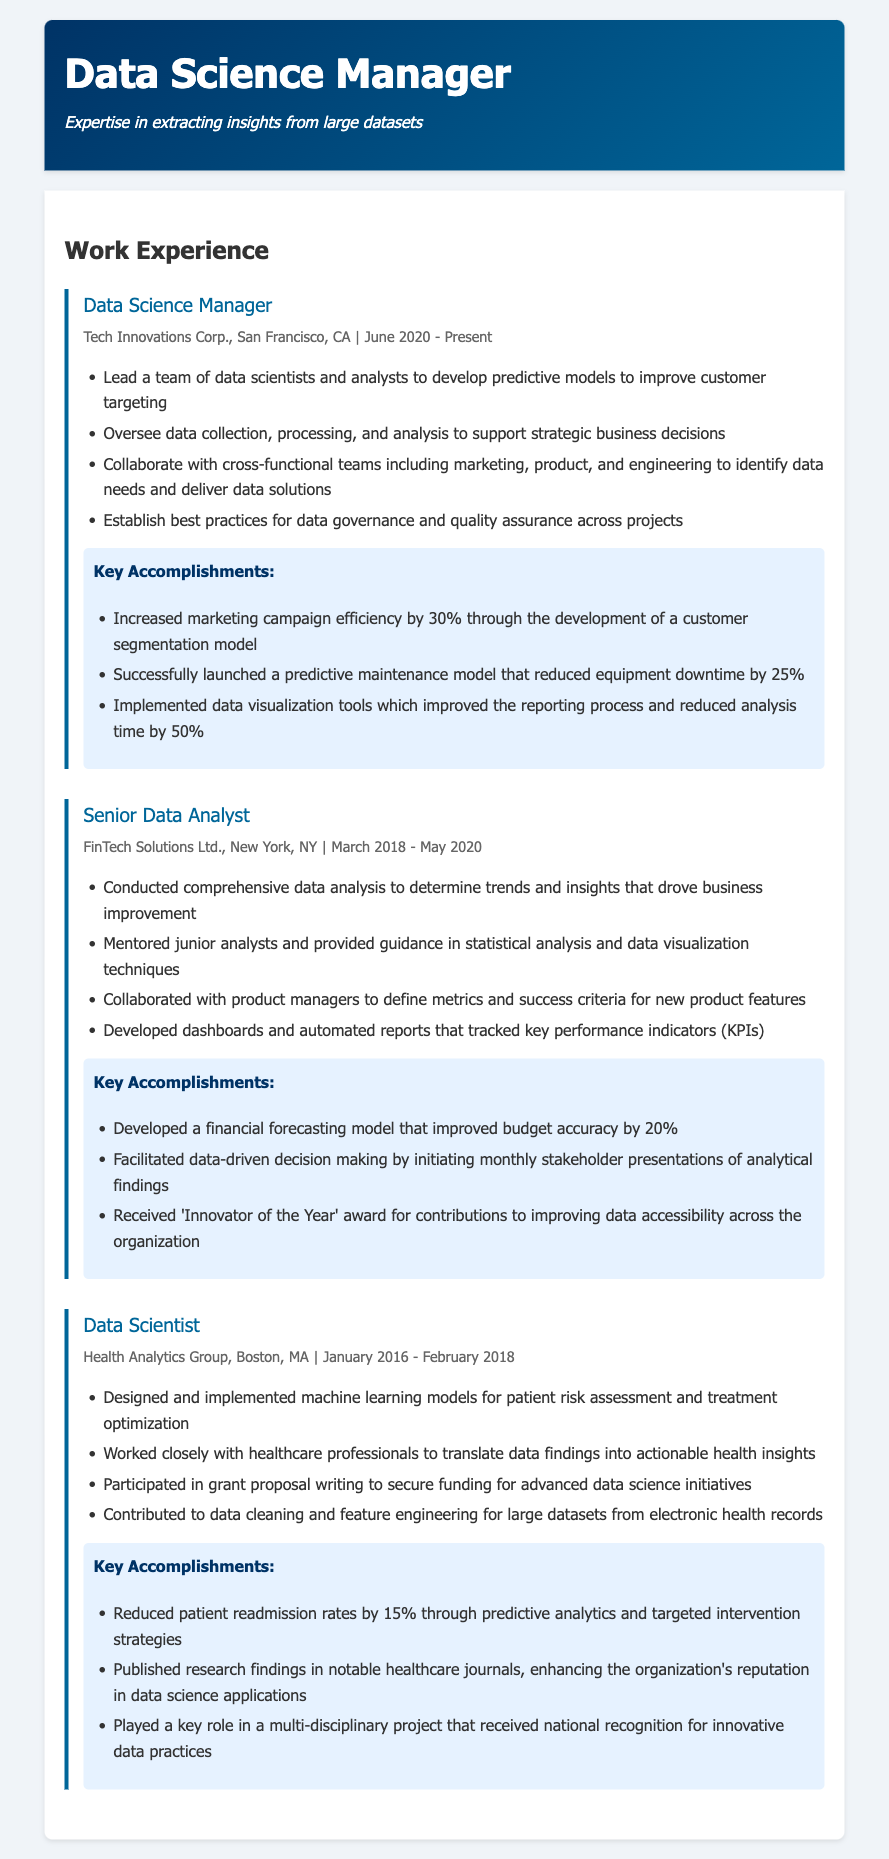What is the current job title of the individual? The job title listed in the document is 'Data Science Manager', which is the most recent role held.
Answer: Data Science Manager Where is the individual currently employed? The document states the current employer as Tech Innovations Corp., located in San Francisco, CA.
Answer: Tech Innovations Corp What year did the individual start their role at FinTech Solutions Ltd.? The role at FinTech Solutions Ltd. began in March 2018, as indicated in the job details.
Answer: March 2018 What percentage did the predictive maintenance model reduce equipment downtime? The accomplishments for the current role specify a 25% reduction in equipment downtime from the predictive maintenance model.
Answer: 25% What significant award was received by the individual during their time at FinTech Solutions Ltd.? The document lists that the individual received the 'Innovator of the Year' award during their tenure at FinTech Solutions Ltd.
Answer: Innovator of the Year How many years did the individual work as a Data Scientist in Health Analytics Group? The timeline provided shows the individual worked there from January 2016 to February 2018, totaling two years.
Answer: Two years What was a key outcome achieved from the development of the customer segmentation model? The key outcome was a 30% increase in marketing campaign efficiency as noted in the accomplishments section.
Answer: 30% Which model improved budget accuracy by 20%? The financial forecasting model developed during the role at FinTech Solutions Ltd. improved budget accuracy.
Answer: Financial forecasting model What type of data-driven decision-making was initiated at FinTech Solutions Ltd.? The document describes monthly stakeholder presentations of analytical findings to facilitate data-driven decision making.
Answer: Monthly stakeholder presentations 